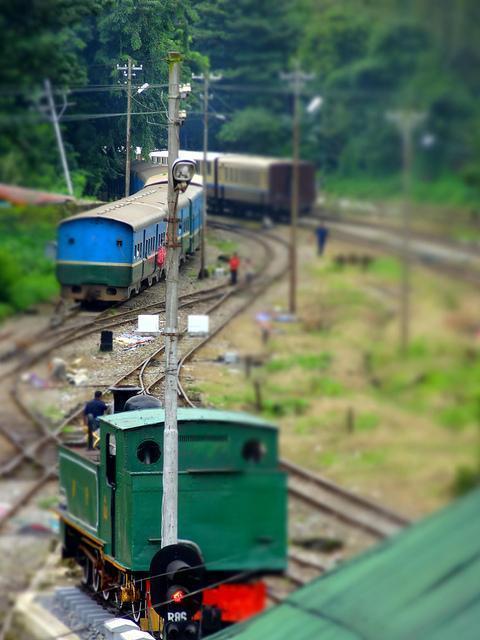How many tracks intersect?
Give a very brief answer. 3. How many train cars are there?
Give a very brief answer. 5. How many trains can be seen?
Give a very brief answer. 3. 